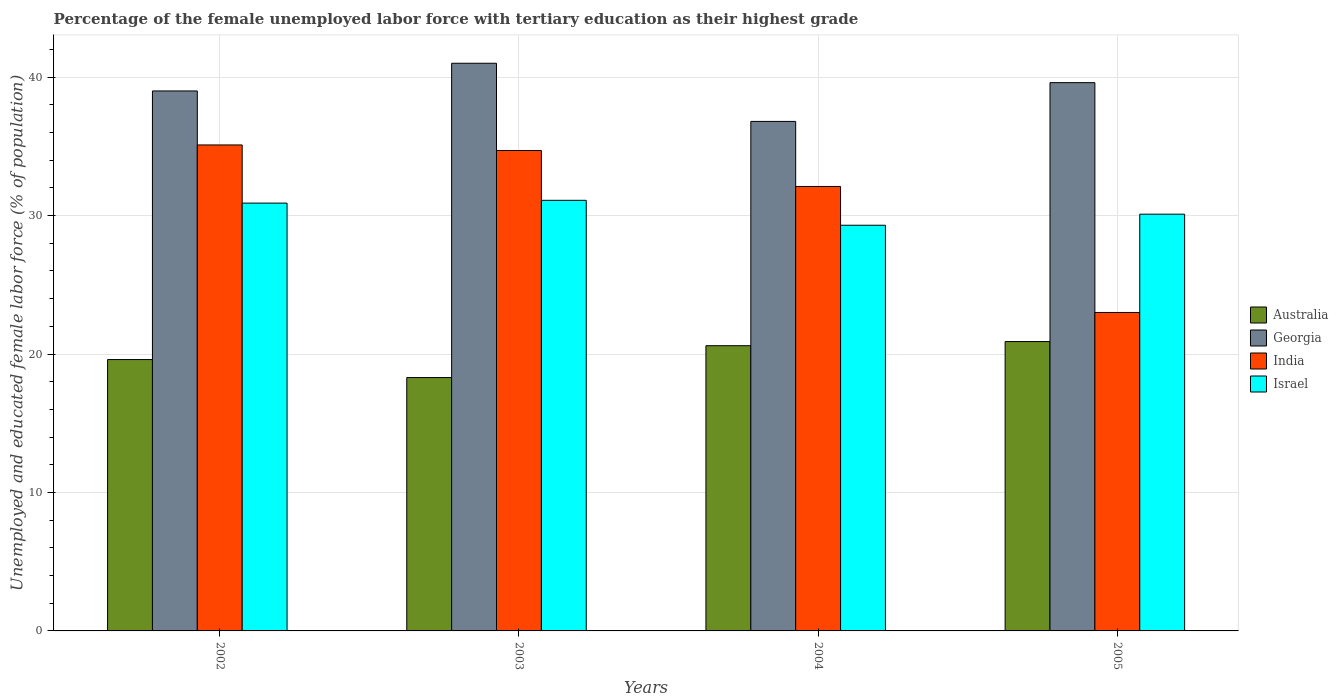Are the number of bars per tick equal to the number of legend labels?
Your response must be concise. Yes. Are the number of bars on each tick of the X-axis equal?
Provide a short and direct response. Yes. What is the label of the 4th group of bars from the left?
Ensure brevity in your answer.  2005. In how many cases, is the number of bars for a given year not equal to the number of legend labels?
Make the answer very short. 0. What is the percentage of the unemployed female labor force with tertiary education in India in 2003?
Your answer should be very brief. 34.7. Across all years, what is the minimum percentage of the unemployed female labor force with tertiary education in Israel?
Offer a very short reply. 29.3. What is the total percentage of the unemployed female labor force with tertiary education in India in the graph?
Keep it short and to the point. 124.9. What is the difference between the percentage of the unemployed female labor force with tertiary education in Georgia in 2003 and the percentage of the unemployed female labor force with tertiary education in Australia in 2002?
Your answer should be very brief. 21.4. What is the average percentage of the unemployed female labor force with tertiary education in Australia per year?
Keep it short and to the point. 19.85. In the year 2002, what is the difference between the percentage of the unemployed female labor force with tertiary education in Israel and percentage of the unemployed female labor force with tertiary education in Georgia?
Give a very brief answer. -8.1. In how many years, is the percentage of the unemployed female labor force with tertiary education in Israel greater than 28 %?
Your answer should be very brief. 4. What is the ratio of the percentage of the unemployed female labor force with tertiary education in India in 2004 to that in 2005?
Your answer should be compact. 1.4. Is the percentage of the unemployed female labor force with tertiary education in Israel in 2002 less than that in 2004?
Provide a succinct answer. No. What is the difference between the highest and the second highest percentage of the unemployed female labor force with tertiary education in Israel?
Offer a very short reply. 0.2. What is the difference between the highest and the lowest percentage of the unemployed female labor force with tertiary education in India?
Make the answer very short. 12.1. Is the sum of the percentage of the unemployed female labor force with tertiary education in Australia in 2003 and 2005 greater than the maximum percentage of the unemployed female labor force with tertiary education in Georgia across all years?
Your answer should be compact. No. Is it the case that in every year, the sum of the percentage of the unemployed female labor force with tertiary education in Israel and percentage of the unemployed female labor force with tertiary education in India is greater than the sum of percentage of the unemployed female labor force with tertiary education in Australia and percentage of the unemployed female labor force with tertiary education in Georgia?
Make the answer very short. No. What does the 4th bar from the left in 2003 represents?
Your answer should be compact. Israel. What does the 1st bar from the right in 2003 represents?
Make the answer very short. Israel. Is it the case that in every year, the sum of the percentage of the unemployed female labor force with tertiary education in Israel and percentage of the unemployed female labor force with tertiary education in Australia is greater than the percentage of the unemployed female labor force with tertiary education in Georgia?
Provide a succinct answer. Yes. Does the graph contain grids?
Provide a succinct answer. Yes. Where does the legend appear in the graph?
Make the answer very short. Center right. What is the title of the graph?
Keep it short and to the point. Percentage of the female unemployed labor force with tertiary education as their highest grade. Does "Burundi" appear as one of the legend labels in the graph?
Ensure brevity in your answer.  No. What is the label or title of the X-axis?
Make the answer very short. Years. What is the label or title of the Y-axis?
Provide a short and direct response. Unemployed and educated female labor force (% of population). What is the Unemployed and educated female labor force (% of population) in Australia in 2002?
Your answer should be very brief. 19.6. What is the Unemployed and educated female labor force (% of population) in Georgia in 2002?
Give a very brief answer. 39. What is the Unemployed and educated female labor force (% of population) of India in 2002?
Ensure brevity in your answer.  35.1. What is the Unemployed and educated female labor force (% of population) of Israel in 2002?
Provide a short and direct response. 30.9. What is the Unemployed and educated female labor force (% of population) of Australia in 2003?
Provide a short and direct response. 18.3. What is the Unemployed and educated female labor force (% of population) of Georgia in 2003?
Your response must be concise. 41. What is the Unemployed and educated female labor force (% of population) in India in 2003?
Keep it short and to the point. 34.7. What is the Unemployed and educated female labor force (% of population) in Israel in 2003?
Offer a very short reply. 31.1. What is the Unemployed and educated female labor force (% of population) of Australia in 2004?
Your response must be concise. 20.6. What is the Unemployed and educated female labor force (% of population) in Georgia in 2004?
Offer a very short reply. 36.8. What is the Unemployed and educated female labor force (% of population) of India in 2004?
Offer a very short reply. 32.1. What is the Unemployed and educated female labor force (% of population) in Israel in 2004?
Give a very brief answer. 29.3. What is the Unemployed and educated female labor force (% of population) of Australia in 2005?
Offer a terse response. 20.9. What is the Unemployed and educated female labor force (% of population) in Georgia in 2005?
Give a very brief answer. 39.6. What is the Unemployed and educated female labor force (% of population) in Israel in 2005?
Make the answer very short. 30.1. Across all years, what is the maximum Unemployed and educated female labor force (% of population) of Australia?
Provide a succinct answer. 20.9. Across all years, what is the maximum Unemployed and educated female labor force (% of population) of India?
Ensure brevity in your answer.  35.1. Across all years, what is the maximum Unemployed and educated female labor force (% of population) of Israel?
Give a very brief answer. 31.1. Across all years, what is the minimum Unemployed and educated female labor force (% of population) in Australia?
Your answer should be compact. 18.3. Across all years, what is the minimum Unemployed and educated female labor force (% of population) in Georgia?
Your answer should be compact. 36.8. Across all years, what is the minimum Unemployed and educated female labor force (% of population) in Israel?
Keep it short and to the point. 29.3. What is the total Unemployed and educated female labor force (% of population) of Australia in the graph?
Offer a very short reply. 79.4. What is the total Unemployed and educated female labor force (% of population) in Georgia in the graph?
Offer a terse response. 156.4. What is the total Unemployed and educated female labor force (% of population) of India in the graph?
Keep it short and to the point. 124.9. What is the total Unemployed and educated female labor force (% of population) in Israel in the graph?
Your response must be concise. 121.4. What is the difference between the Unemployed and educated female labor force (% of population) in Australia in 2002 and that in 2003?
Make the answer very short. 1.3. What is the difference between the Unemployed and educated female labor force (% of population) of Israel in 2002 and that in 2003?
Provide a succinct answer. -0.2. What is the difference between the Unemployed and educated female labor force (% of population) in India in 2002 and that in 2004?
Provide a short and direct response. 3. What is the difference between the Unemployed and educated female labor force (% of population) in Australia in 2002 and that in 2005?
Provide a short and direct response. -1.3. What is the difference between the Unemployed and educated female labor force (% of population) in Israel in 2002 and that in 2005?
Offer a terse response. 0.8. What is the difference between the Unemployed and educated female labor force (% of population) of India in 2003 and that in 2004?
Offer a terse response. 2.6. What is the difference between the Unemployed and educated female labor force (% of population) of Israel in 2003 and that in 2004?
Provide a short and direct response. 1.8. What is the difference between the Unemployed and educated female labor force (% of population) of Australia in 2003 and that in 2005?
Make the answer very short. -2.6. What is the difference between the Unemployed and educated female labor force (% of population) of Georgia in 2003 and that in 2005?
Provide a succinct answer. 1.4. What is the difference between the Unemployed and educated female labor force (% of population) of India in 2003 and that in 2005?
Your answer should be very brief. 11.7. What is the difference between the Unemployed and educated female labor force (% of population) of Australia in 2004 and that in 2005?
Offer a terse response. -0.3. What is the difference between the Unemployed and educated female labor force (% of population) in Georgia in 2004 and that in 2005?
Keep it short and to the point. -2.8. What is the difference between the Unemployed and educated female labor force (% of population) in Australia in 2002 and the Unemployed and educated female labor force (% of population) in Georgia in 2003?
Your response must be concise. -21.4. What is the difference between the Unemployed and educated female labor force (% of population) of Australia in 2002 and the Unemployed and educated female labor force (% of population) of India in 2003?
Give a very brief answer. -15.1. What is the difference between the Unemployed and educated female labor force (% of population) of Australia in 2002 and the Unemployed and educated female labor force (% of population) of Israel in 2003?
Ensure brevity in your answer.  -11.5. What is the difference between the Unemployed and educated female labor force (% of population) of Georgia in 2002 and the Unemployed and educated female labor force (% of population) of India in 2003?
Ensure brevity in your answer.  4.3. What is the difference between the Unemployed and educated female labor force (% of population) of Georgia in 2002 and the Unemployed and educated female labor force (% of population) of Israel in 2003?
Your answer should be compact. 7.9. What is the difference between the Unemployed and educated female labor force (% of population) of India in 2002 and the Unemployed and educated female labor force (% of population) of Israel in 2003?
Provide a short and direct response. 4. What is the difference between the Unemployed and educated female labor force (% of population) of Australia in 2002 and the Unemployed and educated female labor force (% of population) of Georgia in 2004?
Provide a succinct answer. -17.2. What is the difference between the Unemployed and educated female labor force (% of population) in Australia in 2002 and the Unemployed and educated female labor force (% of population) in India in 2004?
Ensure brevity in your answer.  -12.5. What is the difference between the Unemployed and educated female labor force (% of population) of Australia in 2002 and the Unemployed and educated female labor force (% of population) of Israel in 2004?
Provide a short and direct response. -9.7. What is the difference between the Unemployed and educated female labor force (% of population) of India in 2002 and the Unemployed and educated female labor force (% of population) of Israel in 2004?
Provide a succinct answer. 5.8. What is the difference between the Unemployed and educated female labor force (% of population) in Australia in 2002 and the Unemployed and educated female labor force (% of population) in Georgia in 2005?
Offer a very short reply. -20. What is the difference between the Unemployed and educated female labor force (% of population) of Australia in 2002 and the Unemployed and educated female labor force (% of population) of Israel in 2005?
Offer a terse response. -10.5. What is the difference between the Unemployed and educated female labor force (% of population) of Georgia in 2002 and the Unemployed and educated female labor force (% of population) of India in 2005?
Your response must be concise. 16. What is the difference between the Unemployed and educated female labor force (% of population) of India in 2002 and the Unemployed and educated female labor force (% of population) of Israel in 2005?
Keep it short and to the point. 5. What is the difference between the Unemployed and educated female labor force (% of population) in Australia in 2003 and the Unemployed and educated female labor force (% of population) in Georgia in 2004?
Make the answer very short. -18.5. What is the difference between the Unemployed and educated female labor force (% of population) of Australia in 2003 and the Unemployed and educated female labor force (% of population) of India in 2004?
Your response must be concise. -13.8. What is the difference between the Unemployed and educated female labor force (% of population) in Australia in 2003 and the Unemployed and educated female labor force (% of population) in Israel in 2004?
Your answer should be very brief. -11. What is the difference between the Unemployed and educated female labor force (% of population) in India in 2003 and the Unemployed and educated female labor force (% of population) in Israel in 2004?
Offer a very short reply. 5.4. What is the difference between the Unemployed and educated female labor force (% of population) of Australia in 2003 and the Unemployed and educated female labor force (% of population) of Georgia in 2005?
Ensure brevity in your answer.  -21.3. What is the difference between the Unemployed and educated female labor force (% of population) of Australia in 2003 and the Unemployed and educated female labor force (% of population) of India in 2005?
Offer a terse response. -4.7. What is the difference between the Unemployed and educated female labor force (% of population) in Australia in 2003 and the Unemployed and educated female labor force (% of population) in Israel in 2005?
Provide a succinct answer. -11.8. What is the difference between the Unemployed and educated female labor force (% of population) in Georgia in 2003 and the Unemployed and educated female labor force (% of population) in India in 2005?
Ensure brevity in your answer.  18. What is the difference between the Unemployed and educated female labor force (% of population) in Australia in 2004 and the Unemployed and educated female labor force (% of population) in India in 2005?
Ensure brevity in your answer.  -2.4. What is the difference between the Unemployed and educated female labor force (% of population) of Australia in 2004 and the Unemployed and educated female labor force (% of population) of Israel in 2005?
Offer a terse response. -9.5. What is the difference between the Unemployed and educated female labor force (% of population) in Georgia in 2004 and the Unemployed and educated female labor force (% of population) in India in 2005?
Ensure brevity in your answer.  13.8. What is the difference between the Unemployed and educated female labor force (% of population) of Georgia in 2004 and the Unemployed and educated female labor force (% of population) of Israel in 2005?
Your answer should be very brief. 6.7. What is the difference between the Unemployed and educated female labor force (% of population) of India in 2004 and the Unemployed and educated female labor force (% of population) of Israel in 2005?
Your response must be concise. 2. What is the average Unemployed and educated female labor force (% of population) of Australia per year?
Your answer should be very brief. 19.85. What is the average Unemployed and educated female labor force (% of population) in Georgia per year?
Keep it short and to the point. 39.1. What is the average Unemployed and educated female labor force (% of population) in India per year?
Your answer should be compact. 31.23. What is the average Unemployed and educated female labor force (% of population) of Israel per year?
Provide a succinct answer. 30.35. In the year 2002, what is the difference between the Unemployed and educated female labor force (% of population) of Australia and Unemployed and educated female labor force (% of population) of Georgia?
Your answer should be very brief. -19.4. In the year 2002, what is the difference between the Unemployed and educated female labor force (% of population) of Australia and Unemployed and educated female labor force (% of population) of India?
Keep it short and to the point. -15.5. In the year 2002, what is the difference between the Unemployed and educated female labor force (% of population) of Georgia and Unemployed and educated female labor force (% of population) of India?
Keep it short and to the point. 3.9. In the year 2002, what is the difference between the Unemployed and educated female labor force (% of population) in India and Unemployed and educated female labor force (% of population) in Israel?
Provide a short and direct response. 4.2. In the year 2003, what is the difference between the Unemployed and educated female labor force (% of population) in Australia and Unemployed and educated female labor force (% of population) in Georgia?
Give a very brief answer. -22.7. In the year 2003, what is the difference between the Unemployed and educated female labor force (% of population) in Australia and Unemployed and educated female labor force (% of population) in India?
Make the answer very short. -16.4. In the year 2003, what is the difference between the Unemployed and educated female labor force (% of population) of India and Unemployed and educated female labor force (% of population) of Israel?
Offer a very short reply. 3.6. In the year 2004, what is the difference between the Unemployed and educated female labor force (% of population) in Australia and Unemployed and educated female labor force (% of population) in Georgia?
Keep it short and to the point. -16.2. In the year 2004, what is the difference between the Unemployed and educated female labor force (% of population) of Georgia and Unemployed and educated female labor force (% of population) of India?
Offer a terse response. 4.7. In the year 2004, what is the difference between the Unemployed and educated female labor force (% of population) of India and Unemployed and educated female labor force (% of population) of Israel?
Provide a short and direct response. 2.8. In the year 2005, what is the difference between the Unemployed and educated female labor force (% of population) in Australia and Unemployed and educated female labor force (% of population) in Georgia?
Your response must be concise. -18.7. In the year 2005, what is the difference between the Unemployed and educated female labor force (% of population) in Australia and Unemployed and educated female labor force (% of population) in India?
Keep it short and to the point. -2.1. In the year 2005, what is the difference between the Unemployed and educated female labor force (% of population) in Australia and Unemployed and educated female labor force (% of population) in Israel?
Offer a terse response. -9.2. In the year 2005, what is the difference between the Unemployed and educated female labor force (% of population) in Georgia and Unemployed and educated female labor force (% of population) in India?
Offer a terse response. 16.6. What is the ratio of the Unemployed and educated female labor force (% of population) of Australia in 2002 to that in 2003?
Offer a very short reply. 1.07. What is the ratio of the Unemployed and educated female labor force (% of population) of Georgia in 2002 to that in 2003?
Your answer should be compact. 0.95. What is the ratio of the Unemployed and educated female labor force (% of population) of India in 2002 to that in 2003?
Offer a terse response. 1.01. What is the ratio of the Unemployed and educated female labor force (% of population) of Israel in 2002 to that in 2003?
Provide a short and direct response. 0.99. What is the ratio of the Unemployed and educated female labor force (% of population) in Australia in 2002 to that in 2004?
Give a very brief answer. 0.95. What is the ratio of the Unemployed and educated female labor force (% of population) of Georgia in 2002 to that in 2004?
Your response must be concise. 1.06. What is the ratio of the Unemployed and educated female labor force (% of population) in India in 2002 to that in 2004?
Make the answer very short. 1.09. What is the ratio of the Unemployed and educated female labor force (% of population) of Israel in 2002 to that in 2004?
Keep it short and to the point. 1.05. What is the ratio of the Unemployed and educated female labor force (% of population) of Australia in 2002 to that in 2005?
Your answer should be very brief. 0.94. What is the ratio of the Unemployed and educated female labor force (% of population) in Georgia in 2002 to that in 2005?
Give a very brief answer. 0.98. What is the ratio of the Unemployed and educated female labor force (% of population) of India in 2002 to that in 2005?
Your answer should be compact. 1.53. What is the ratio of the Unemployed and educated female labor force (% of population) of Israel in 2002 to that in 2005?
Give a very brief answer. 1.03. What is the ratio of the Unemployed and educated female labor force (% of population) in Australia in 2003 to that in 2004?
Your answer should be compact. 0.89. What is the ratio of the Unemployed and educated female labor force (% of population) in Georgia in 2003 to that in 2004?
Your answer should be very brief. 1.11. What is the ratio of the Unemployed and educated female labor force (% of population) in India in 2003 to that in 2004?
Offer a terse response. 1.08. What is the ratio of the Unemployed and educated female labor force (% of population) in Israel in 2003 to that in 2004?
Your answer should be very brief. 1.06. What is the ratio of the Unemployed and educated female labor force (% of population) of Australia in 2003 to that in 2005?
Your answer should be very brief. 0.88. What is the ratio of the Unemployed and educated female labor force (% of population) in Georgia in 2003 to that in 2005?
Offer a very short reply. 1.04. What is the ratio of the Unemployed and educated female labor force (% of population) of India in 2003 to that in 2005?
Give a very brief answer. 1.51. What is the ratio of the Unemployed and educated female labor force (% of population) of Israel in 2003 to that in 2005?
Provide a succinct answer. 1.03. What is the ratio of the Unemployed and educated female labor force (% of population) of Australia in 2004 to that in 2005?
Make the answer very short. 0.99. What is the ratio of the Unemployed and educated female labor force (% of population) in Georgia in 2004 to that in 2005?
Provide a short and direct response. 0.93. What is the ratio of the Unemployed and educated female labor force (% of population) in India in 2004 to that in 2005?
Your answer should be very brief. 1.4. What is the ratio of the Unemployed and educated female labor force (% of population) in Israel in 2004 to that in 2005?
Provide a succinct answer. 0.97. What is the difference between the highest and the second highest Unemployed and educated female labor force (% of population) in Georgia?
Keep it short and to the point. 1.4. What is the difference between the highest and the second highest Unemployed and educated female labor force (% of population) in Israel?
Offer a very short reply. 0.2. What is the difference between the highest and the lowest Unemployed and educated female labor force (% of population) of Australia?
Provide a short and direct response. 2.6. What is the difference between the highest and the lowest Unemployed and educated female labor force (% of population) of India?
Keep it short and to the point. 12.1. 